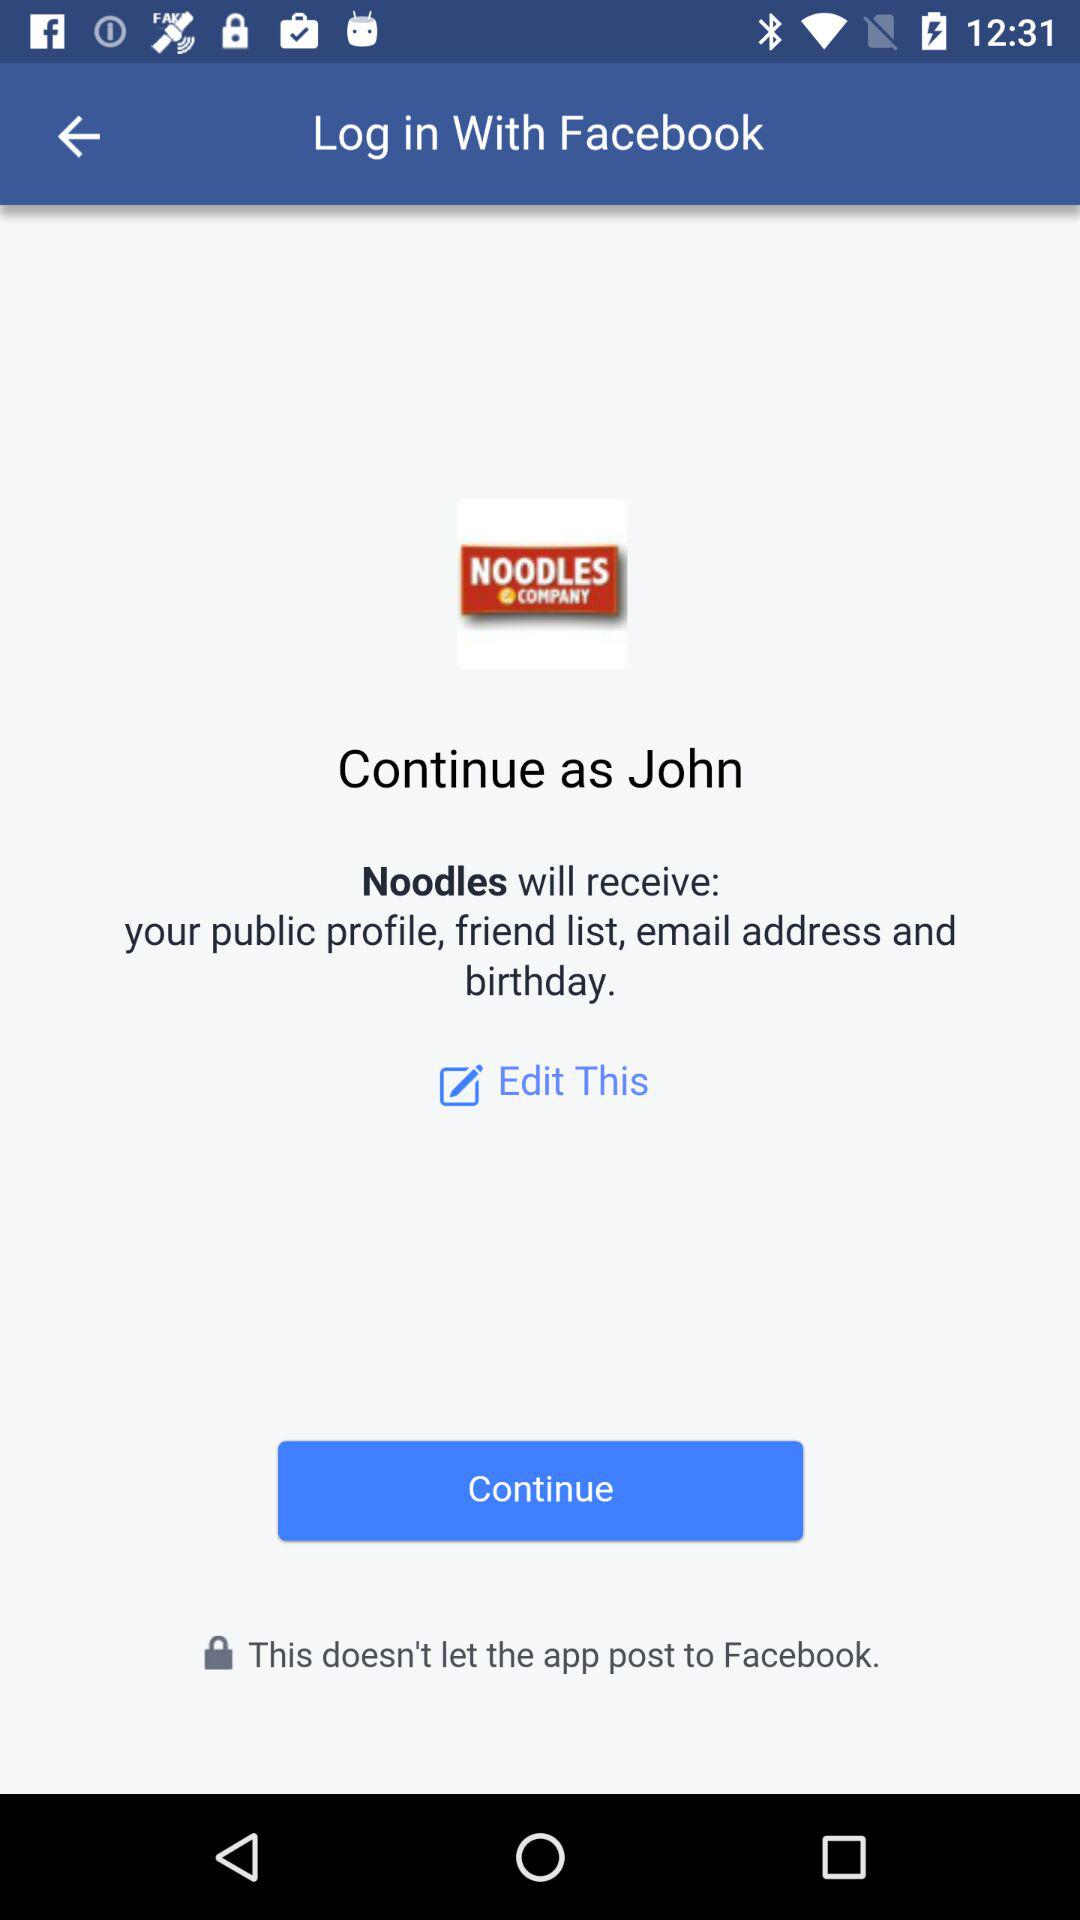Who will receive the public profile, friend list, email address and birthday? The public profile, friend list, email address and birthday will be received by "Noodles". 